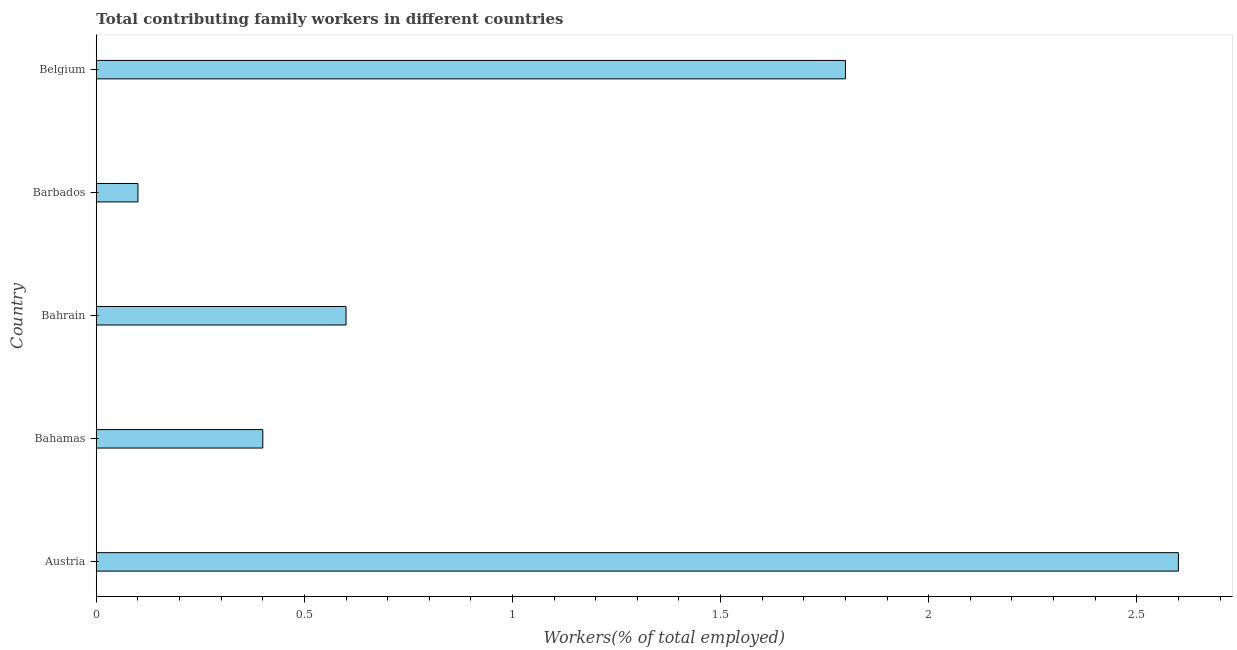Does the graph contain any zero values?
Make the answer very short. No. Does the graph contain grids?
Offer a terse response. No. What is the title of the graph?
Your answer should be very brief. Total contributing family workers in different countries. What is the label or title of the X-axis?
Your answer should be compact. Workers(% of total employed). What is the contributing family workers in Barbados?
Your answer should be compact. 0.1. Across all countries, what is the maximum contributing family workers?
Provide a succinct answer. 2.6. Across all countries, what is the minimum contributing family workers?
Your answer should be very brief. 0.1. In which country was the contributing family workers maximum?
Keep it short and to the point. Austria. In which country was the contributing family workers minimum?
Your response must be concise. Barbados. What is the sum of the contributing family workers?
Offer a very short reply. 5.5. What is the difference between the contributing family workers in Bahrain and Barbados?
Provide a short and direct response. 0.5. What is the average contributing family workers per country?
Give a very brief answer. 1.1. What is the median contributing family workers?
Give a very brief answer. 0.6. In how many countries, is the contributing family workers greater than 1 %?
Provide a succinct answer. 2. Is the contributing family workers in Barbados less than that in Belgium?
Make the answer very short. Yes. Is the difference between the contributing family workers in Austria and Barbados greater than the difference between any two countries?
Your response must be concise. Yes. What is the difference between the highest and the second highest contributing family workers?
Offer a very short reply. 0.8. Is the sum of the contributing family workers in Bahrain and Belgium greater than the maximum contributing family workers across all countries?
Make the answer very short. No. What is the difference between the highest and the lowest contributing family workers?
Make the answer very short. 2.5. How many bars are there?
Your answer should be compact. 5. How many countries are there in the graph?
Give a very brief answer. 5. What is the Workers(% of total employed) in Austria?
Ensure brevity in your answer.  2.6. What is the Workers(% of total employed) in Bahamas?
Your answer should be compact. 0.4. What is the Workers(% of total employed) of Bahrain?
Give a very brief answer. 0.6. What is the Workers(% of total employed) of Barbados?
Ensure brevity in your answer.  0.1. What is the Workers(% of total employed) of Belgium?
Make the answer very short. 1.8. What is the difference between the Workers(% of total employed) in Austria and Bahrain?
Your answer should be very brief. 2. What is the difference between the Workers(% of total employed) in Austria and Belgium?
Keep it short and to the point. 0.8. What is the difference between the Workers(% of total employed) in Bahamas and Belgium?
Your response must be concise. -1.4. What is the difference between the Workers(% of total employed) in Bahrain and Barbados?
Offer a terse response. 0.5. What is the difference between the Workers(% of total employed) in Bahrain and Belgium?
Offer a terse response. -1.2. What is the ratio of the Workers(% of total employed) in Austria to that in Bahrain?
Give a very brief answer. 4.33. What is the ratio of the Workers(% of total employed) in Austria to that in Belgium?
Provide a succinct answer. 1.44. What is the ratio of the Workers(% of total employed) in Bahamas to that in Bahrain?
Give a very brief answer. 0.67. What is the ratio of the Workers(% of total employed) in Bahamas to that in Barbados?
Your answer should be compact. 4. What is the ratio of the Workers(% of total employed) in Bahamas to that in Belgium?
Keep it short and to the point. 0.22. What is the ratio of the Workers(% of total employed) in Bahrain to that in Barbados?
Your answer should be compact. 6. What is the ratio of the Workers(% of total employed) in Bahrain to that in Belgium?
Offer a very short reply. 0.33. What is the ratio of the Workers(% of total employed) in Barbados to that in Belgium?
Keep it short and to the point. 0.06. 